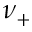<formula> <loc_0><loc_0><loc_500><loc_500>\nu _ { + }</formula> 